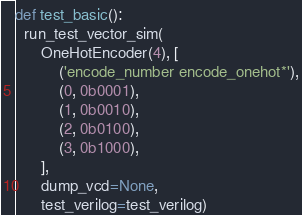Convert code to text. <code><loc_0><loc_0><loc_500><loc_500><_Python_>def test_basic():
  run_test_vector_sim(
      OneHotEncoder(4), [
          ('encode_number encode_onehot*'),
          (0, 0b0001),
          (1, 0b0010),
          (2, 0b0100),
          (3, 0b1000),
      ],
      dump_vcd=None,
      test_verilog=test_verilog)
</code> 